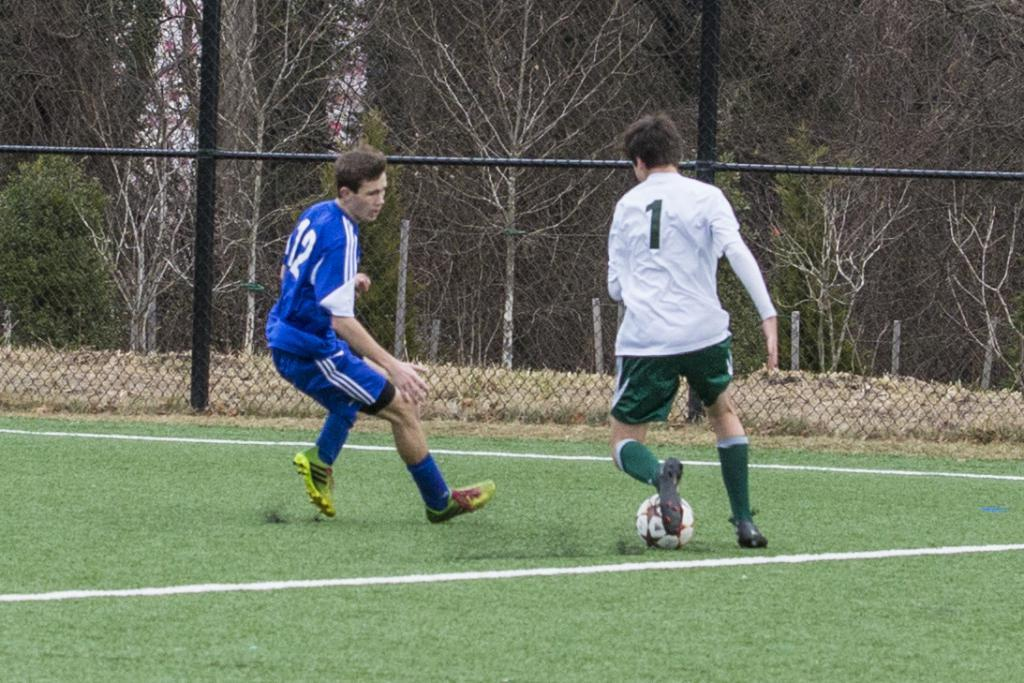<image>
Share a concise interpretation of the image provided. Number 1 on the white team tries to get past number 12 on the blue team. 